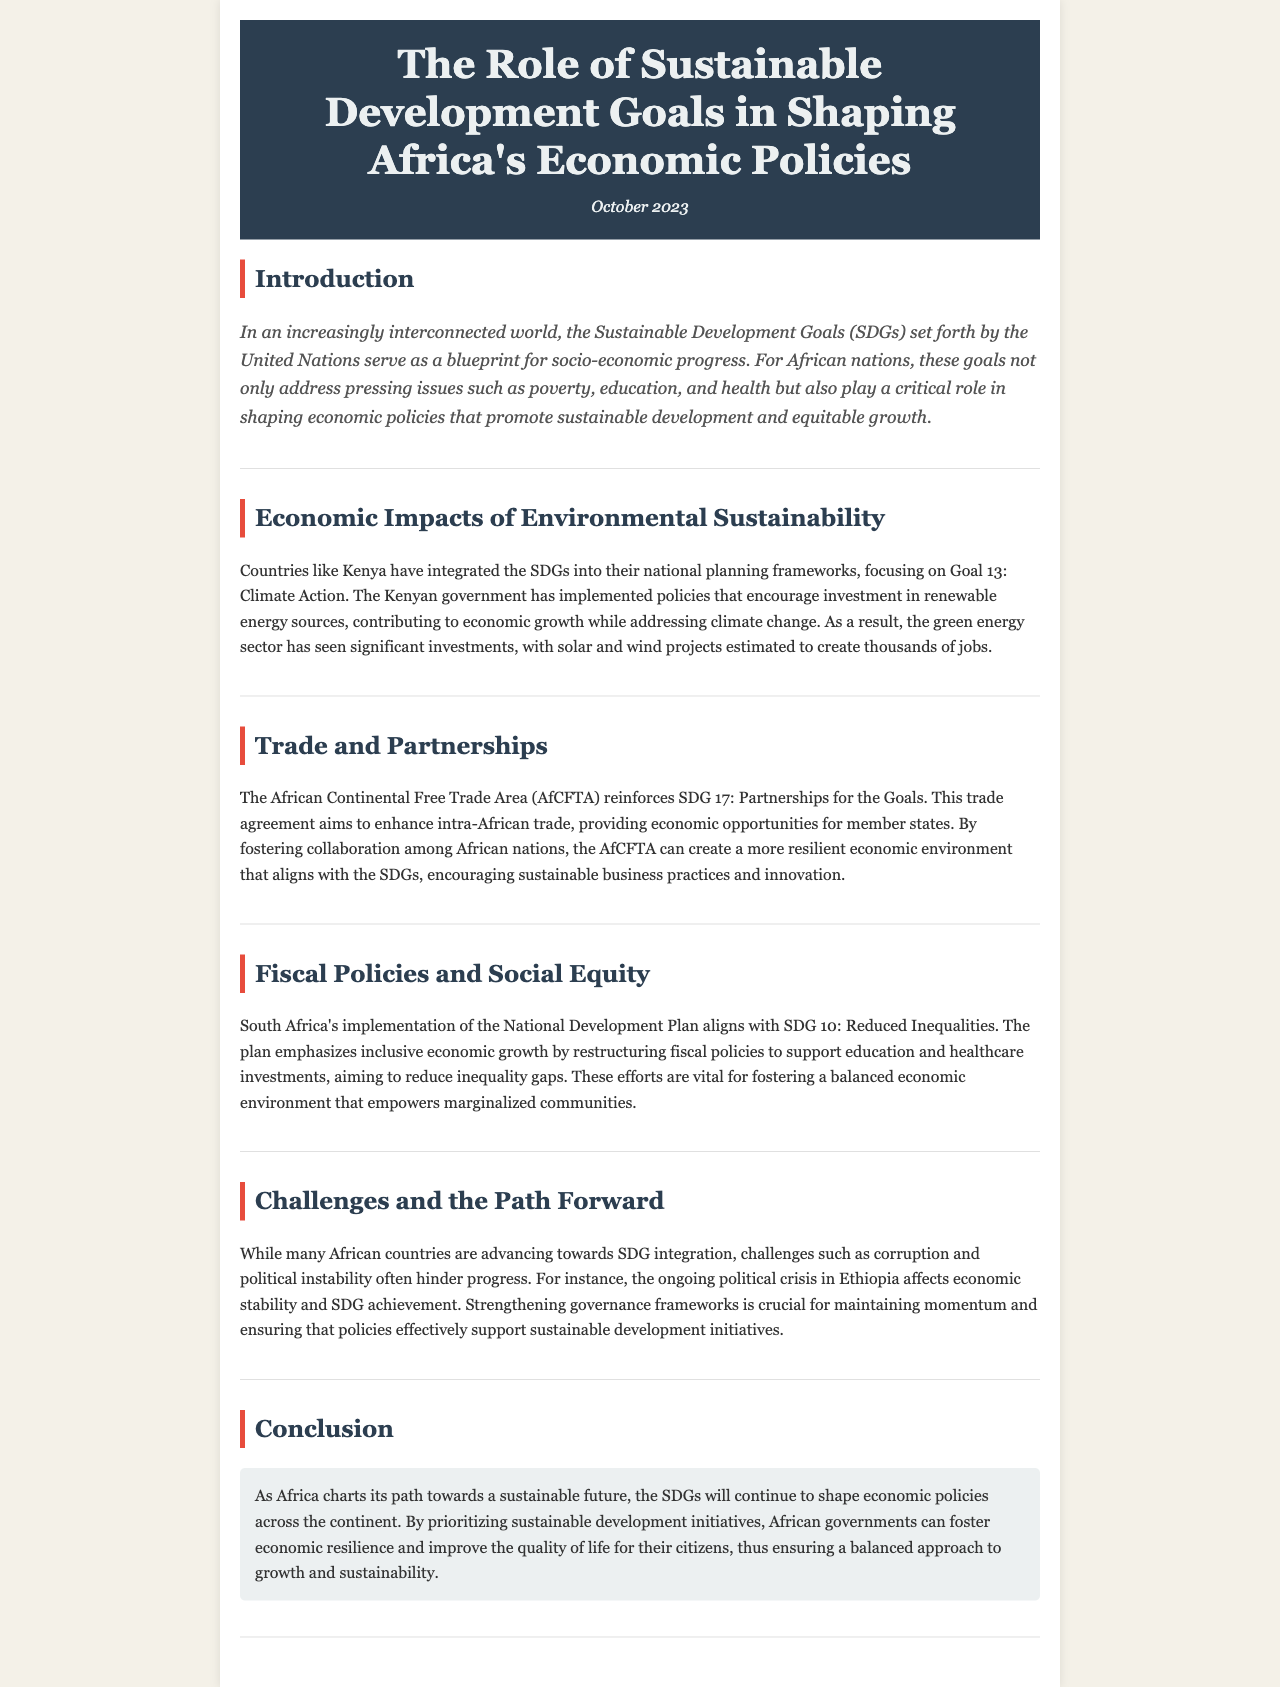what is the title of the newsletter? The title is presented at the top of the document, indicating the main focus of the content.
Answer: The Role of Sustainable Development Goals in Shaping Africa's Economic Policies when was the newsletter published? The publication date is mentioned directly after the title in the header section of the document.
Answer: October 2023 which country is mentioned as integrating the SDGs into their national planning frameworks? The document discusses the efforts of a specific country related to SDG integration within an economic context.
Answer: Kenya what is the goal focused on climate action? The specific Sustainable Development Goal addressing climate change is highlighted in the economic impacts section of the newsletter.
Answer: Goal 13 which region's trade agreement is mentioned to reinforce partnerships for the goals? The document highlights a specific trade agreement aimed at enhancing trade among African nations as part of the partnerships for sustainable development.
Answer: African Continental Free Trade Area (AfCFTA) what is South Africa's plan that aligns with reduced inequalities? The document specifically names the development strategy utilized by South Africa that targets inequality reduction.
Answer: National Development Plan which two challenges are mentioned that hinder progress towards SDG integration? The document discusses specific obstacles that many African nations face in their pursuit of sustainable development goals.
Answer: Corruption and political instability what is the primary focus of the conclusion section? The conclusion summarizes the overarching theme and aim regarding SDG integration in Africa's future economic policies.
Answer: The SDGs will continue to shape economic policies across the continent 